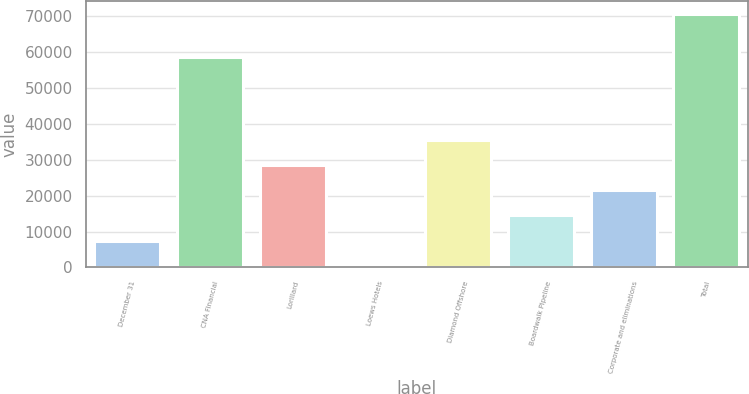Convert chart. <chart><loc_0><loc_0><loc_500><loc_500><bar_chart><fcel>December 31<fcel>CNA Financial<fcel>Lorillard<fcel>Loews Hotels<fcel>Diamond Offshore<fcel>Boardwalk Pipeline<fcel>Corporate and eliminations<fcel>Total<nl><fcel>7463.65<fcel>58730<fcel>28534.3<fcel>440.1<fcel>35557.8<fcel>14487.2<fcel>21510.8<fcel>70675.6<nl></chart> 